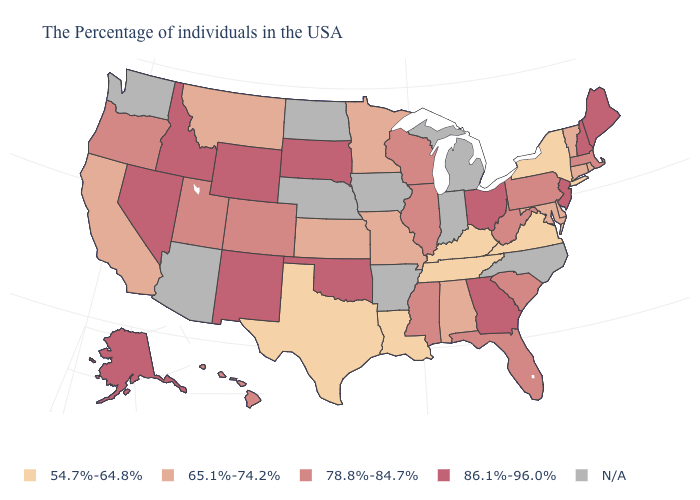Among the states that border Oklahoma , does New Mexico have the highest value?
Answer briefly. Yes. What is the value of Virginia?
Quick response, please. 54.7%-64.8%. Name the states that have a value in the range 78.8%-84.7%?
Write a very short answer. Massachusetts, Pennsylvania, South Carolina, West Virginia, Florida, Wisconsin, Illinois, Mississippi, Colorado, Utah, Oregon, Hawaii. What is the value of Utah?
Keep it brief. 78.8%-84.7%. What is the value of Vermont?
Write a very short answer. 65.1%-74.2%. What is the value of Washington?
Be succinct. N/A. What is the value of Connecticut?
Write a very short answer. 65.1%-74.2%. What is the value of Arkansas?
Concise answer only. N/A. Name the states that have a value in the range 54.7%-64.8%?
Answer briefly. New York, Virginia, Kentucky, Tennessee, Louisiana, Texas. What is the value of Alabama?
Answer briefly. 65.1%-74.2%. What is the value of Rhode Island?
Concise answer only. 65.1%-74.2%. What is the highest value in the USA?
Concise answer only. 86.1%-96.0%. What is the lowest value in the USA?
Short answer required. 54.7%-64.8%. What is the lowest value in the MidWest?
Answer briefly. 65.1%-74.2%. What is the value of Oklahoma?
Short answer required. 86.1%-96.0%. 